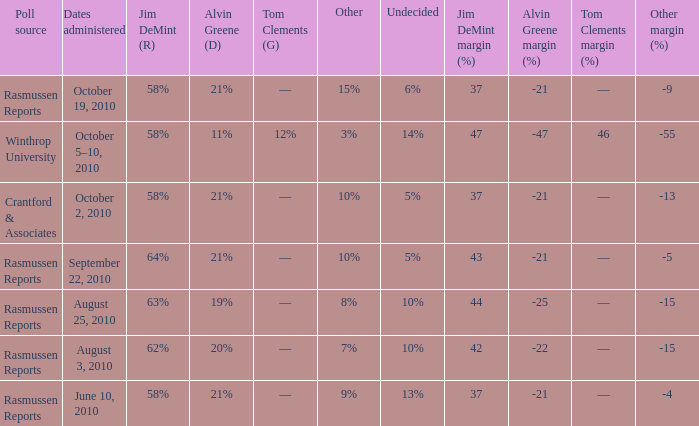Which poll source determined undecided of 5% and Jim DeMint (R) of 58%? Crantford & Associates. Give me the full table as a dictionary. {'header': ['Poll source', 'Dates administered', 'Jim DeMint (R)', 'Alvin Greene (D)', 'Tom Clements (G)', 'Other', 'Undecided', 'Jim DeMint margin (%)', 'Alvin Greene margin (%)', 'Tom Clements margin (%)', 'Other margin (%) '], 'rows': [['Rasmussen Reports', 'October 19, 2010', '58%', '21%', '––', '15%', '6%', '37', '-21', '––', '-9'], ['Winthrop University', 'October 5–10, 2010', '58%', '11%', '12%', '3%', '14%', '47', '-47', '46', '-55'], ['Crantford & Associates', 'October 2, 2010', '58%', '21%', '––', '10%', '5%', '37', '-21', '––', '-13'], ['Rasmussen Reports', 'September 22, 2010', '64%', '21%', '––', '10%', '5%', '43', '-21', '––', '-5'], ['Rasmussen Reports', 'August 25, 2010', '63%', '19%', '––', '8%', '10%', '44', '-25', '––', '-15'], ['Rasmussen Reports', 'August 3, 2010', '62%', '20%', '––', '7%', '10%', '42', '-22', '––', '-15'], ['Rasmussen Reports', 'June 10, 2010', '58%', '21%', '––', '9%', '13%', '37', '-21', '––', '-4']]} 